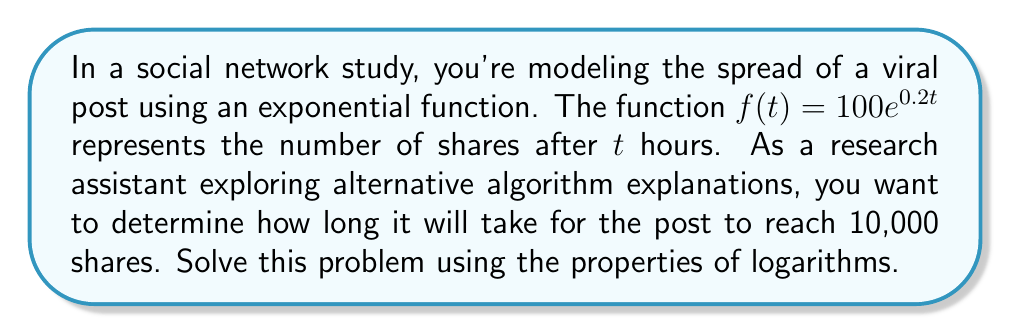Solve this math problem. 1) We start with the exponential function:
   $f(t) = 100e^{0.2t}$

2) We want to find $t$ when $f(t) = 10,000$:
   $10,000 = 100e^{0.2t}$

3) Divide both sides by 100:
   $100 = e^{0.2t}$

4) Take the natural logarithm of both sides:
   $\ln(100) = \ln(e^{0.2t})$

5) Use the logarithm property $\ln(e^x) = x$:
   $\ln(100) = 0.2t$

6) Solve for $t$:
   $t = \frac{\ln(100)}{0.2}$

7) Calculate the result:
   $t = \frac{4.60517}{0.2} \approx 23.02585$

Therefore, it will take approximately 23.03 hours for the post to reach 10,000 shares.
Answer: 23.03 hours 